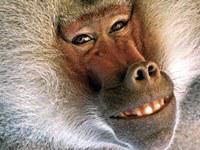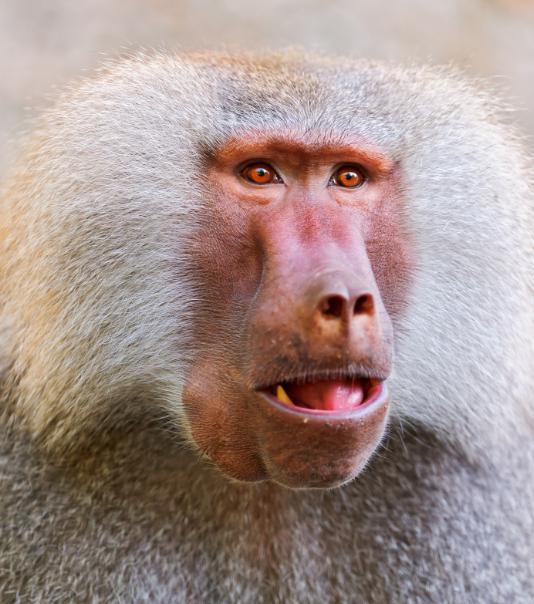The first image is the image on the left, the second image is the image on the right. Given the left and right images, does the statement "Teeth are visible in the baboons in each image." hold true? Answer yes or no. Yes. 